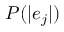<formula> <loc_0><loc_0><loc_500><loc_500>P ( | e _ { j } | )</formula> 